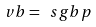Convert formula to latex. <formula><loc_0><loc_0><loc_500><loc_500>\ v b = \ s g b p</formula> 